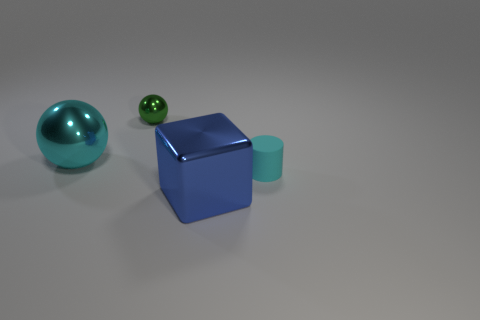Can you tell me how many objects are in this image? There are four objects in the image: a large teal sphere, a small green sphere, a blue cube, and a cyan cylinder. 